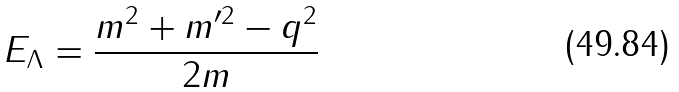Convert formula to latex. <formula><loc_0><loc_0><loc_500><loc_500>E _ { \Lambda } = \frac { m ^ { 2 } + m ^ { \prime 2 } - q ^ { 2 } } { 2 m }</formula> 